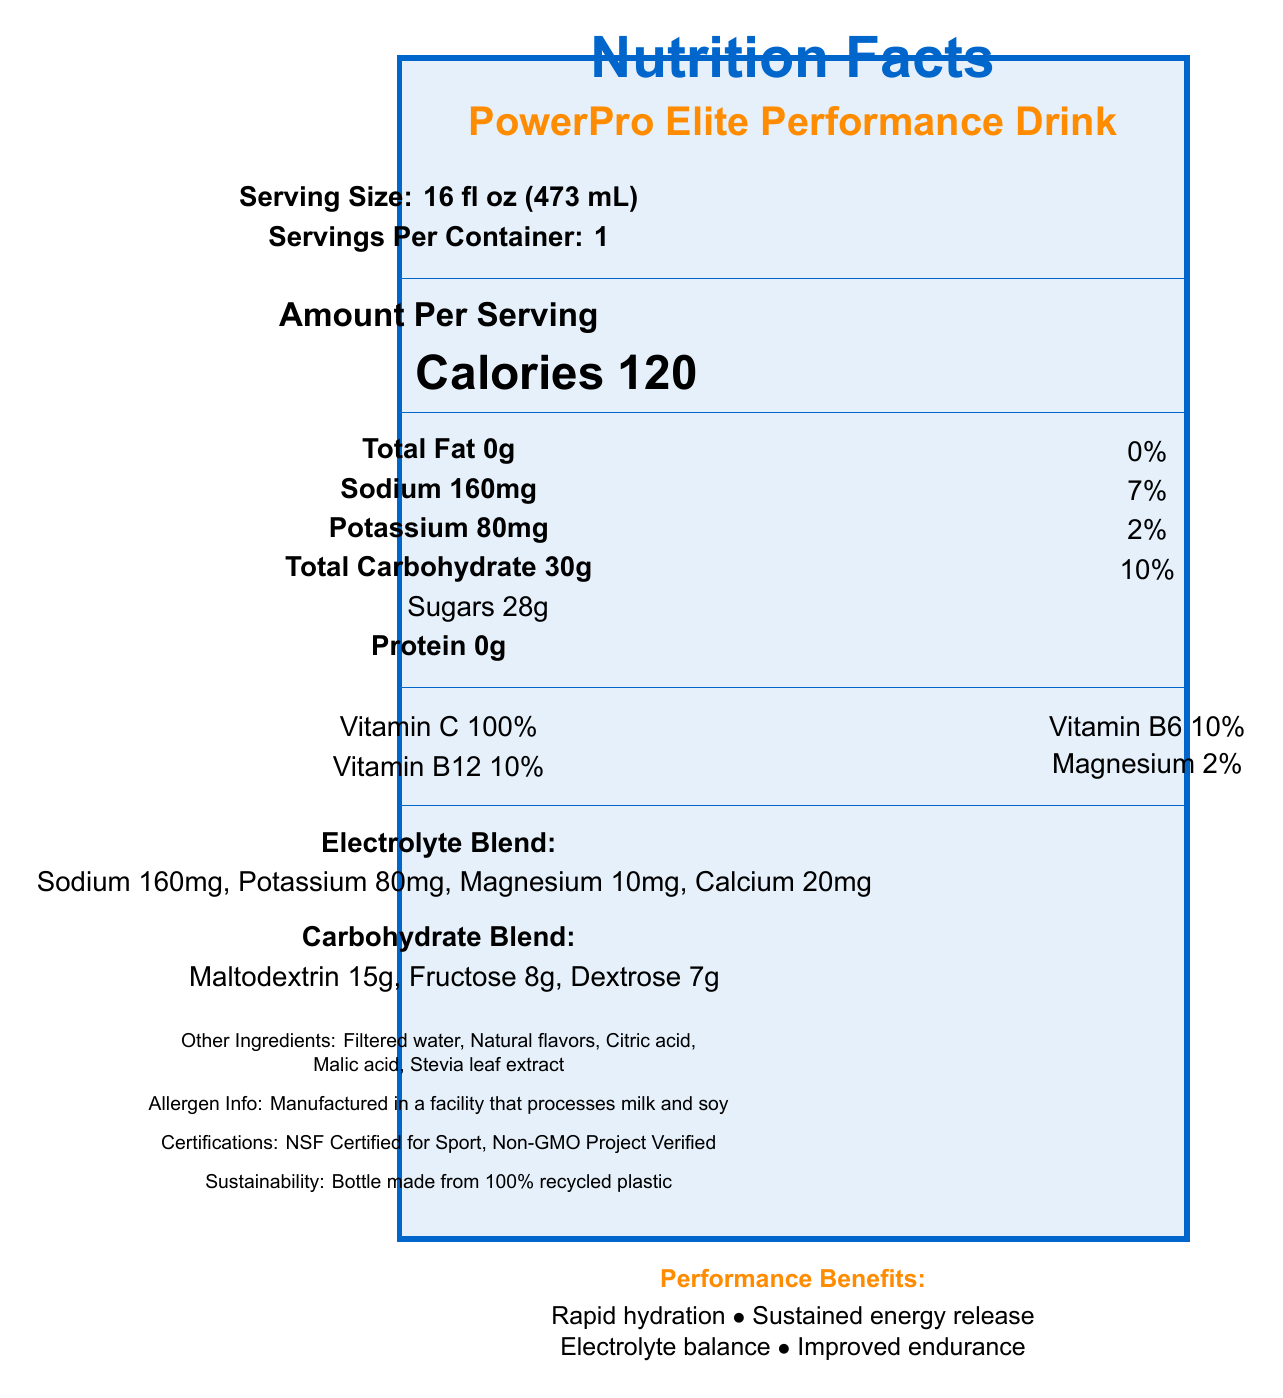what is the serving size? The document states "Serving Size: 16 fl oz (473 mL)" under the Serving Information section.
Answer: 16 fl oz (473 mL) how many calories are in a serving? The document shows "Calories 120" in the Main Content section.
Answer: 120 calories how much sodium is in a serving? The document lists "Sodium 160mg" in the Nutrient Table.
Answer: 160mg what is the total carbohydrate content per serving? It is mentioned in the Nutrient Table as "Total Carbohydrate 30g."
Answer: 30g what are the other ingredients? The section "Other Ingredients" lists these ingredients explicitly.
Answer: Filtered water, Natural flavors, Citric acid, Malic acid, Stevia leaf extract which vitamin has the highest percentage? A. Vitamin C B. Vitamin B6 C. Vitamin B12 The document shows "Vitamin C 100%" which is the highest percentage compared to Vitamin B6 (10%) and Vitamin B12 (10%).
Answer: A. Vitamin C what is a performance benefit of this drink? A. Rapid hydration B. Increased protein intake C. Weight loss The document lists "Rapid hydration" as one of the performance benefits. The other options are not listed.
Answer: A. Rapid hydration are there any allergens mentioned? The document mentions, "Manufactured in a facility that processes milk and soy" under Allergen Info.
Answer: Yes is the bottle made from recycled plastic? The document states "Bottle made from 100% recycled plastic" under Sustainability.
Answer: Yes summarize the main purpose of the document. The main purpose is to provide detailed nutritional information and benefits of the PowerPro Elite Performance Drink.
Answer: The document is a detailed Nutrition Facts label for the PowerPro Elite Performance Drink, highlighting serving size, calories, nutrient content, electrolyte and carbohydrate blend, other ingredients, performance benefits, allergen information, certifications, and sustainability. what percentage of daily value does the protein in one serving provide? The document lists Protein as 0g but does not provide a corresponding daily value percentage.
Answer: Cannot be determined 